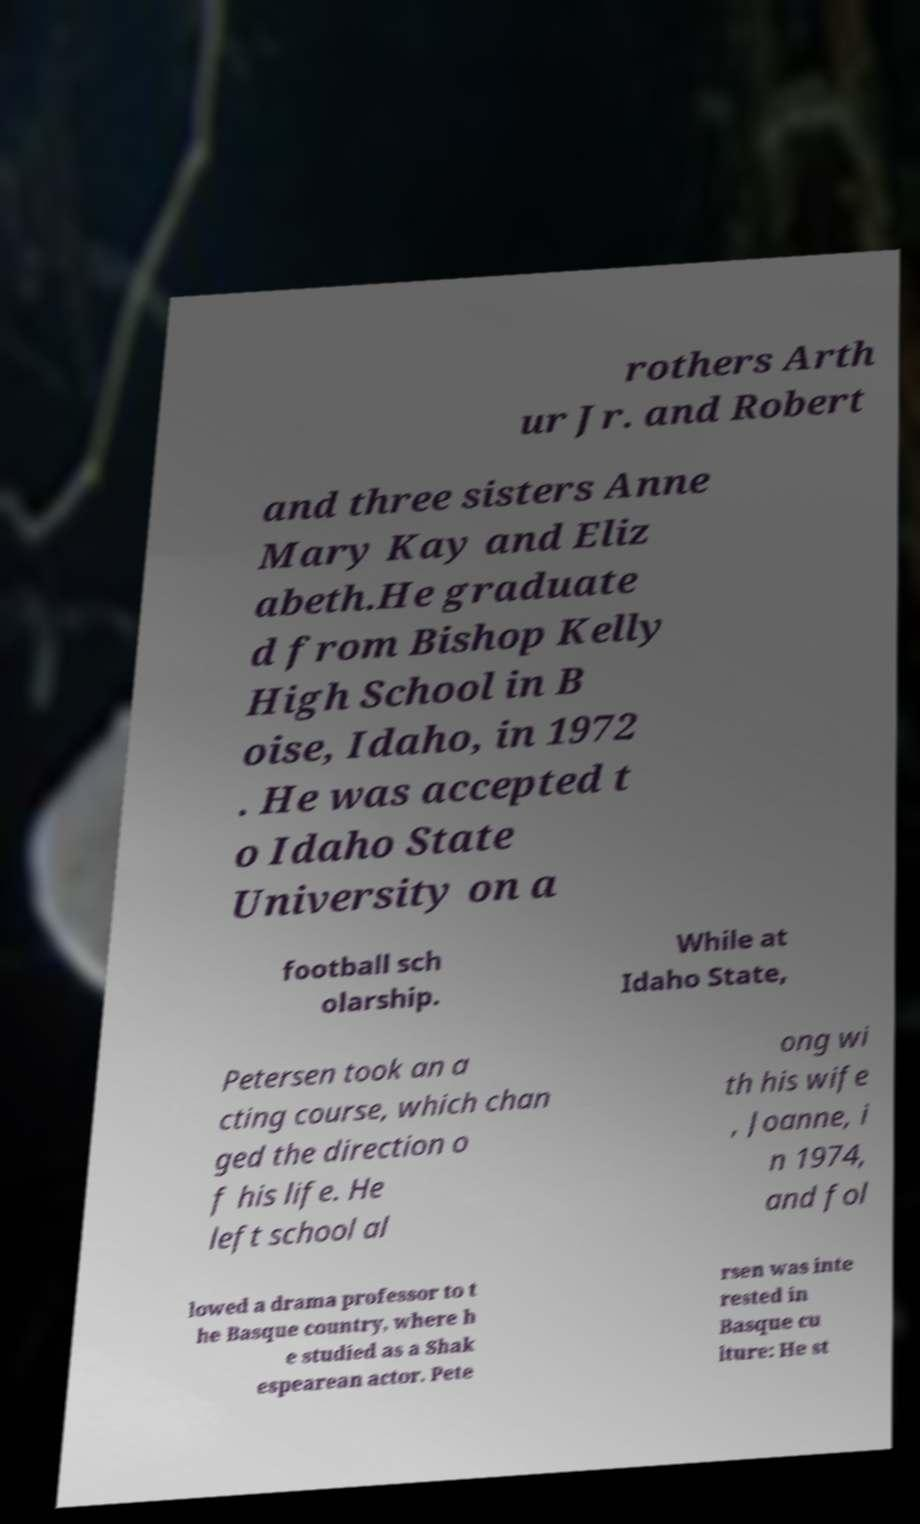I need the written content from this picture converted into text. Can you do that? rothers Arth ur Jr. and Robert and three sisters Anne Mary Kay and Eliz abeth.He graduate d from Bishop Kelly High School in B oise, Idaho, in 1972 . He was accepted t o Idaho State University on a football sch olarship. While at Idaho State, Petersen took an a cting course, which chan ged the direction o f his life. He left school al ong wi th his wife , Joanne, i n 1974, and fol lowed a drama professor to t he Basque country, where h e studied as a Shak espearean actor. Pete rsen was inte rested in Basque cu lture: He st 